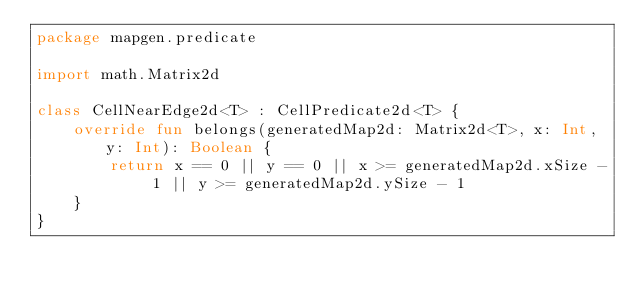<code> <loc_0><loc_0><loc_500><loc_500><_Kotlin_>package mapgen.predicate

import math.Matrix2d

class CellNearEdge2d<T> : CellPredicate2d<T> {
    override fun belongs(generatedMap2d: Matrix2d<T>, x: Int, y: Int): Boolean {
        return x == 0 || y == 0 || x >= generatedMap2d.xSize - 1 || y >= generatedMap2d.ySize - 1
    }
}</code> 